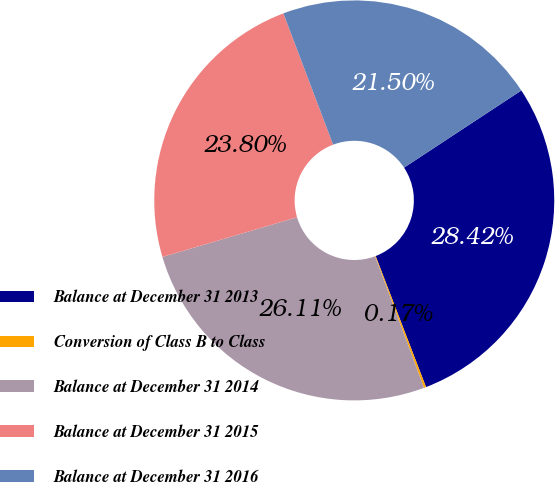Convert chart. <chart><loc_0><loc_0><loc_500><loc_500><pie_chart><fcel>Balance at December 31 2013<fcel>Conversion of Class B to Class<fcel>Balance at December 31 2014<fcel>Balance at December 31 2015<fcel>Balance at December 31 2016<nl><fcel>28.42%<fcel>0.17%<fcel>26.11%<fcel>23.8%<fcel>21.5%<nl></chart> 